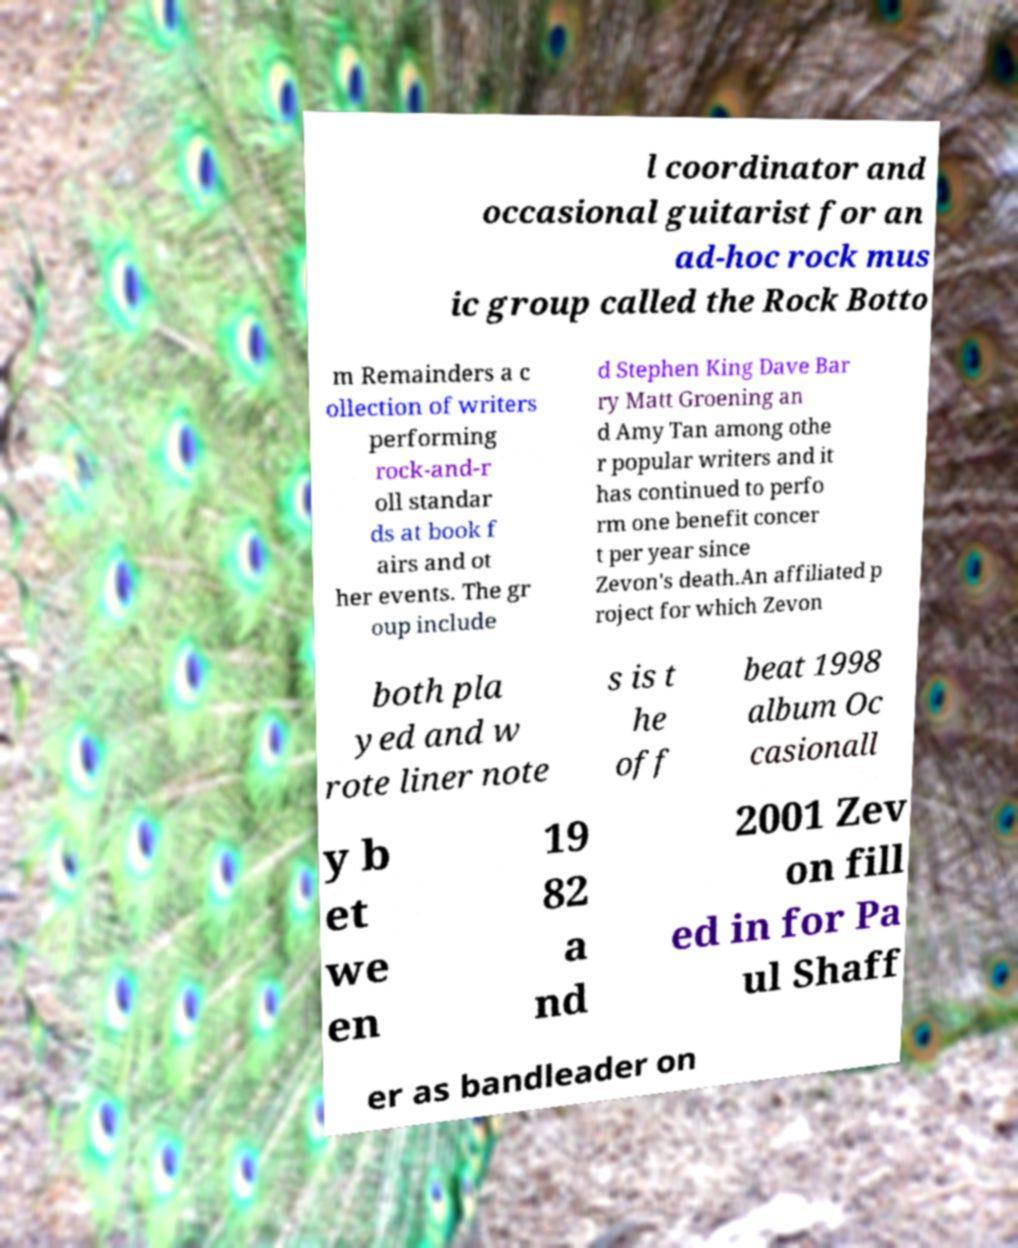Could you assist in decoding the text presented in this image and type it out clearly? l coordinator and occasional guitarist for an ad-hoc rock mus ic group called the Rock Botto m Remainders a c ollection of writers performing rock-and-r oll standar ds at book f airs and ot her events. The gr oup include d Stephen King Dave Bar ry Matt Groening an d Amy Tan among othe r popular writers and it has continued to perfo rm one benefit concer t per year since Zevon's death.An affiliated p roject for which Zevon both pla yed and w rote liner note s is t he off beat 1998 album Oc casionall y b et we en 19 82 a nd 2001 Zev on fill ed in for Pa ul Shaff er as bandleader on 